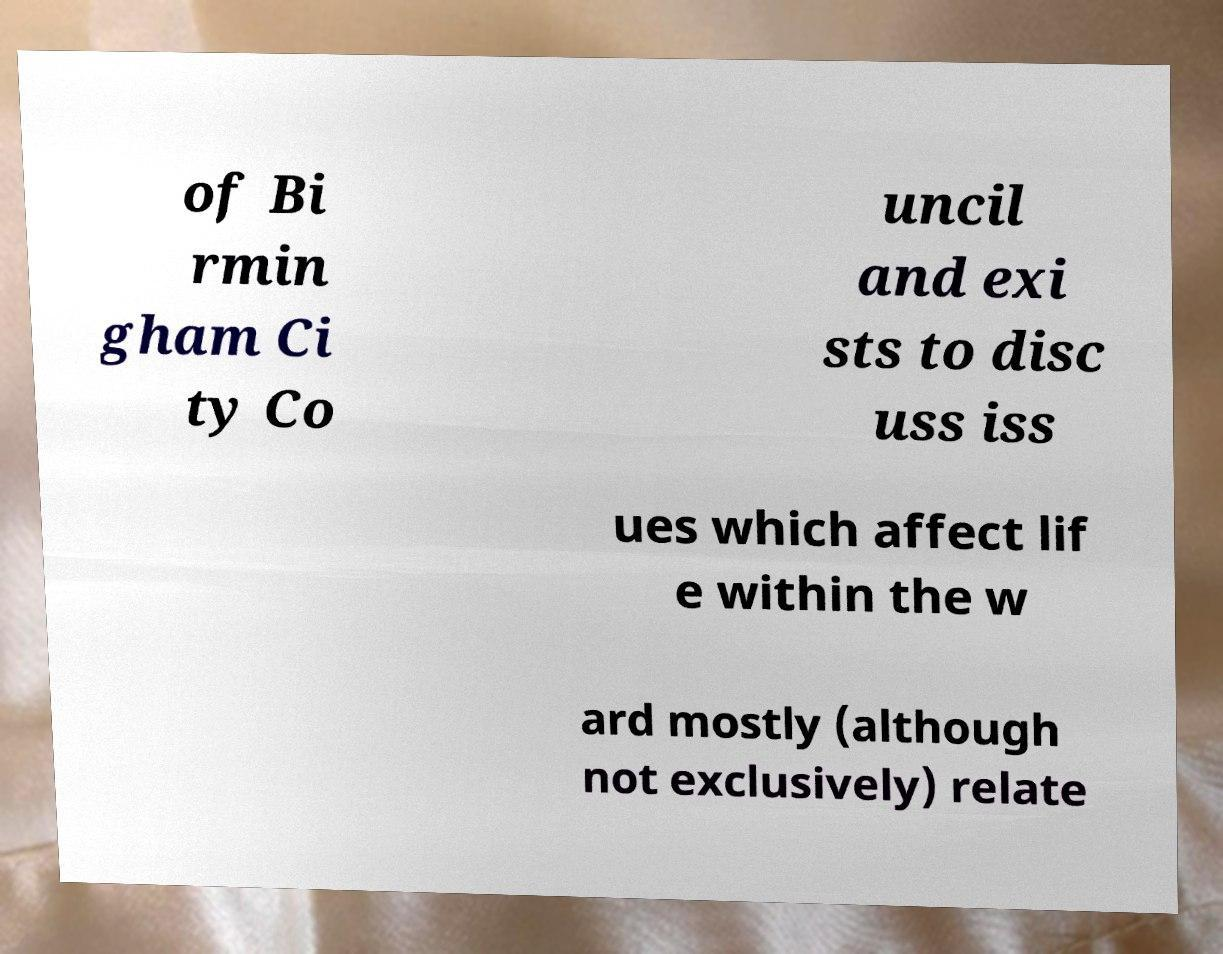For documentation purposes, I need the text within this image transcribed. Could you provide that? of Bi rmin gham Ci ty Co uncil and exi sts to disc uss iss ues which affect lif e within the w ard mostly (although not exclusively) relate 